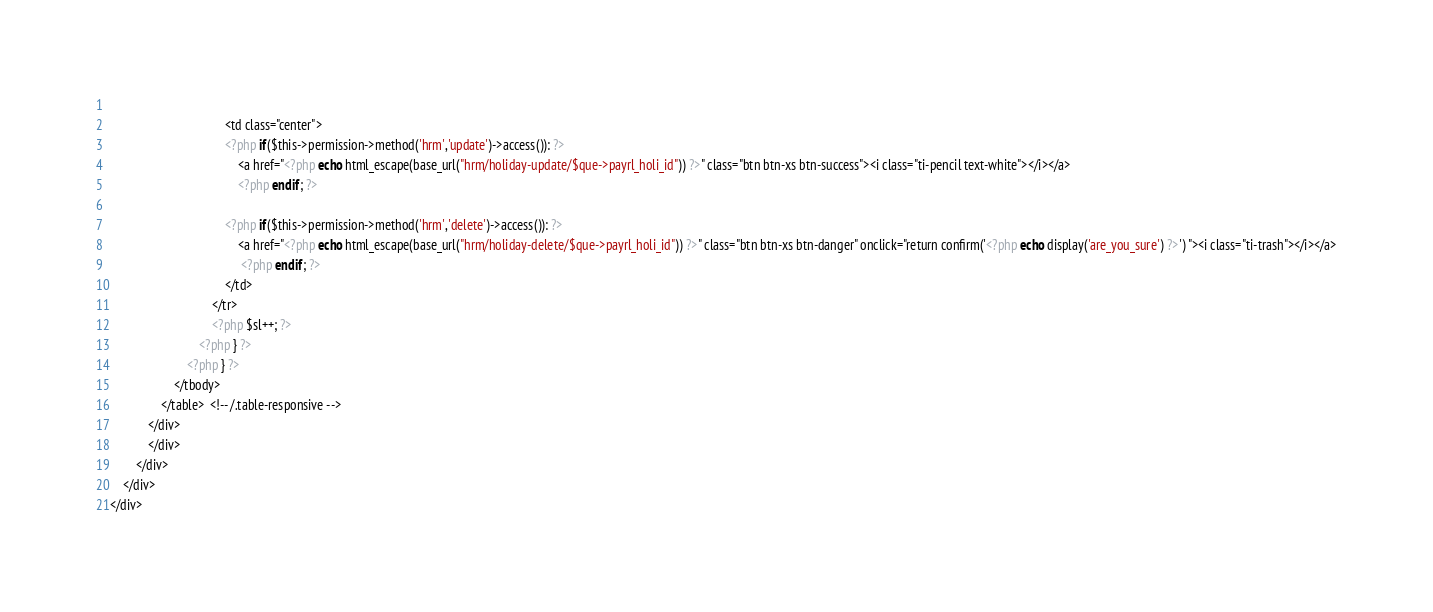Convert code to text. <code><loc_0><loc_0><loc_500><loc_500><_PHP_>                                   
                                    <td class="center">
                                    <?php if($this->permission->method('hrm','update')->access()): ?>
                                        <a href="<?php echo html_escape(base_url("hrm/holiday-update/$que->payrl_holi_id")) ?>" class="btn btn-xs btn-success"><i class="ti-pencil text-white"></i></a>
                                        <?php endif; ?>
                                    
                                    <?php if($this->permission->method('hrm','delete')->access()): ?>  
                                        <a href="<?php echo html_escape(base_url("hrm/holiday-delete/$que->payrl_holi_id")) ?>" class="btn btn-xs btn-danger" onclick="return confirm('<?php echo display('are_you_sure') ?>') "><i class="ti-trash"></i></a>
                                         <?php endif; ?> 
                                    </td>
                                </tr>
                                <?php $sl++; ?>
                            <?php } ?> 
                        <?php } ?> 
                    </tbody>
                </table>  <!-- /.table-responsive -->
            </div>
            </div>
        </div>
    </div>
</div></code> 